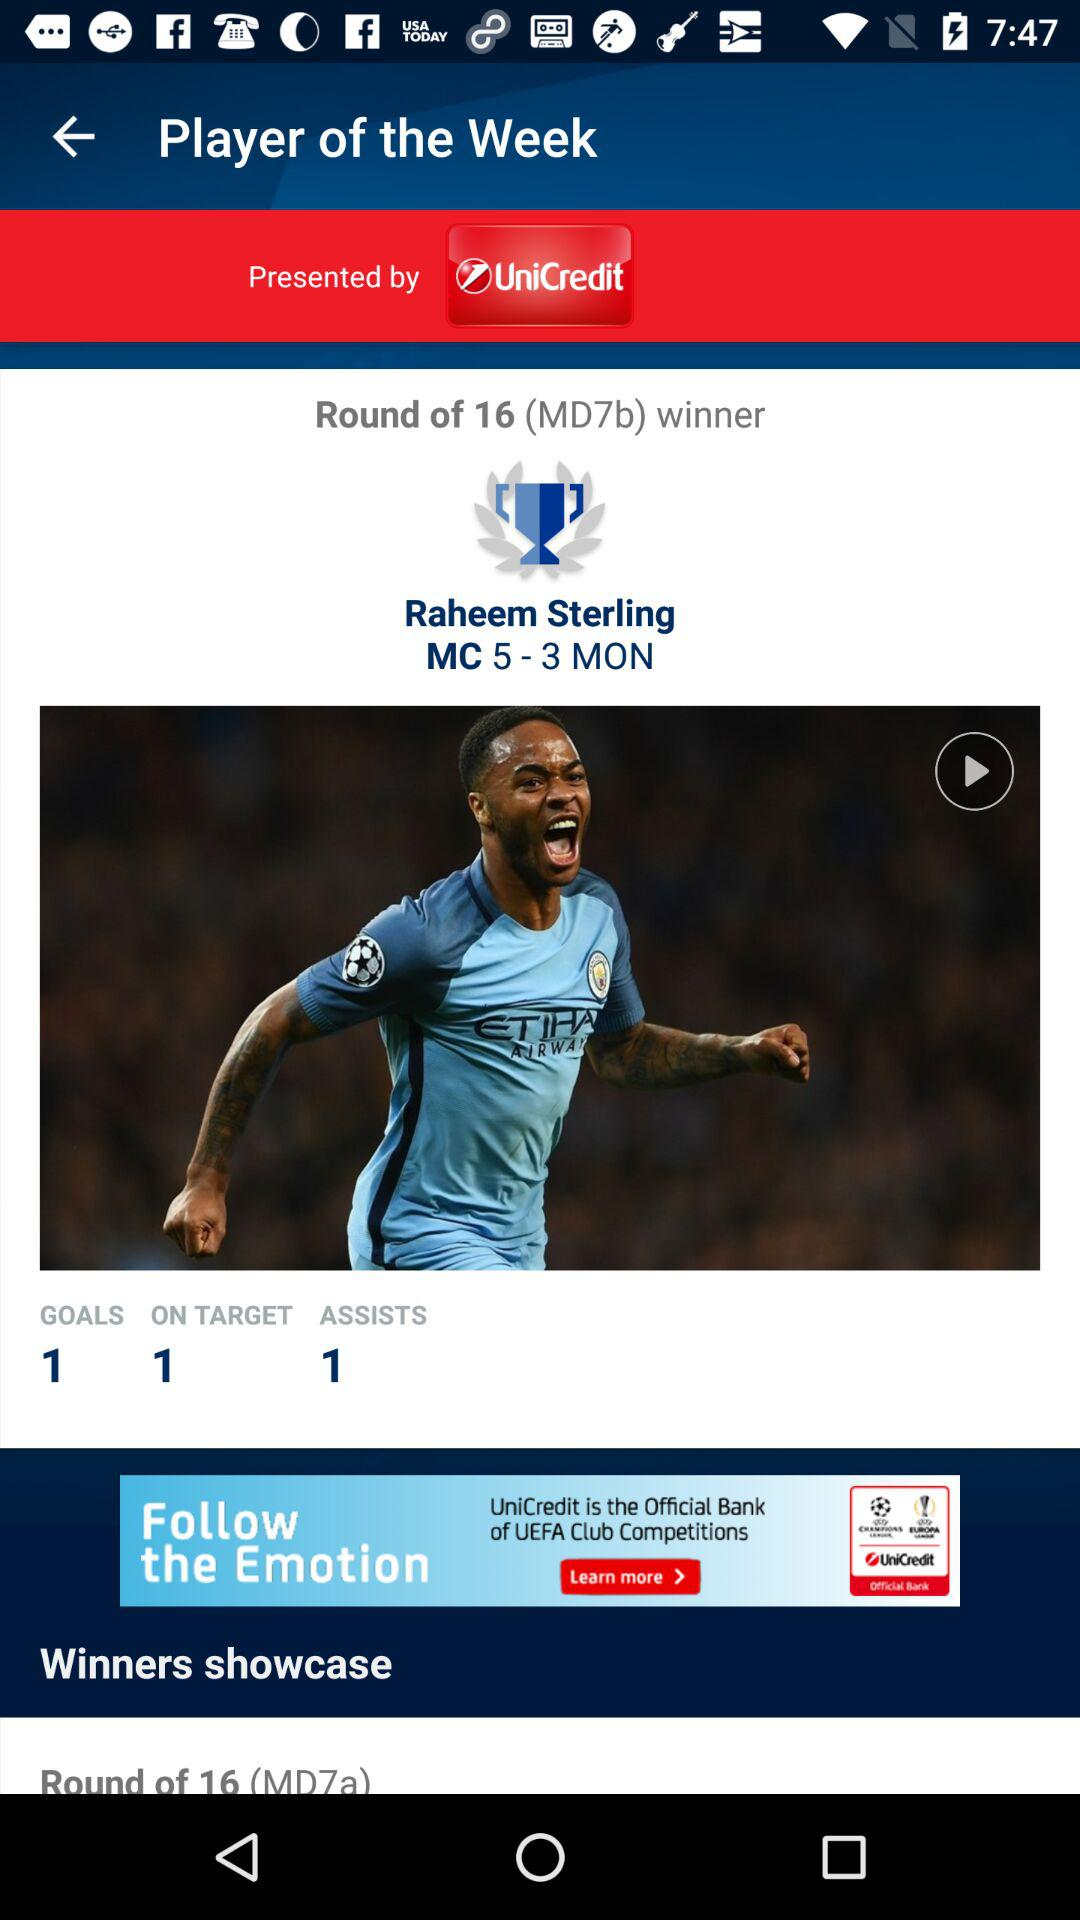How many more assists does the player with 1 assist have than the player with 0 assists?
Answer the question using a single word or phrase. 1 